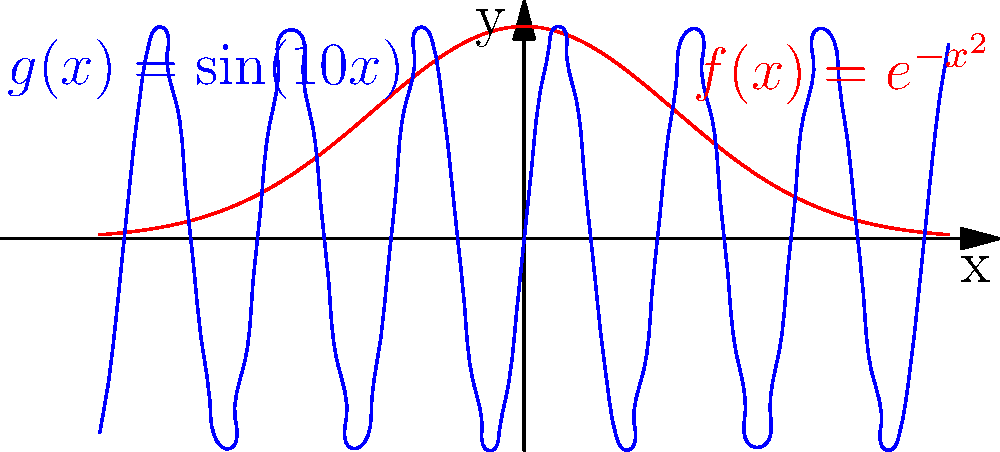In the context of fractal-based encryption using non-Euclidean patterns, consider the functions $f(x) = e^{-x^2}$ and $g(x) = \sin(10x)$ shown in the graph. Which function would be more suitable as a basis for generating a fractal pattern in a hyperbolic space, and why? To determine which function is more suitable for generating a fractal pattern in hyperbolic space for encryption purposes, we need to consider the following steps:

1. Understand the properties of hyperbolic space:
   - Hyperbolic space has negative curvature
   - Parallel lines diverge in hyperbolic space
   - The sum of angles in a triangle is less than 180 degrees

2. Analyze the properties of $f(x) = e^{-x^2}$:
   - It's a Gaussian function
   - It's symmetric around the y-axis
   - It approaches zero as x approaches infinity
   - It has a single peak at x = 0

3. Analyze the properties of $g(x) = \sin(10x)$:
   - It's a periodic function
   - It oscillates between -1 and 1
   - It repeats every $\frac{\pi}{5}$ units
   - It has infinite peaks and troughs

4. Consider fractal properties:
   - Fractals exhibit self-similarity at different scales
   - They have complex, detailed patterns that repeat infinitely
   - They often have non-integer dimensions

5. Evaluate suitability for hyperbolic space:
   - The periodic nature of $g(x)$ aligns better with the repeating patterns in hyperbolic tilings
   - The oscillations of $g(x)$ can be mapped to the curvature of hyperbolic space more naturally
   - The infinite repetition of $g(x)$ supports the creation of intricate, self-similar patterns

6. Consider encryption strength:
   - The complexity and repetition of $g(x)$ provide more opportunities for creating complex encryption patterns
   - The periodic nature of $g(x)$ allows for easier generation of keys based on phase shifts or frequency modulations

Therefore, $g(x) = \sin(10x)$ is more suitable for generating a fractal pattern in hyperbolic space for encryption purposes due to its periodic nature, infinite repetition, and potential for creating complex, self-similar patterns that align well with hyperbolic geometry.
Answer: $g(x) = \sin(10x)$ 